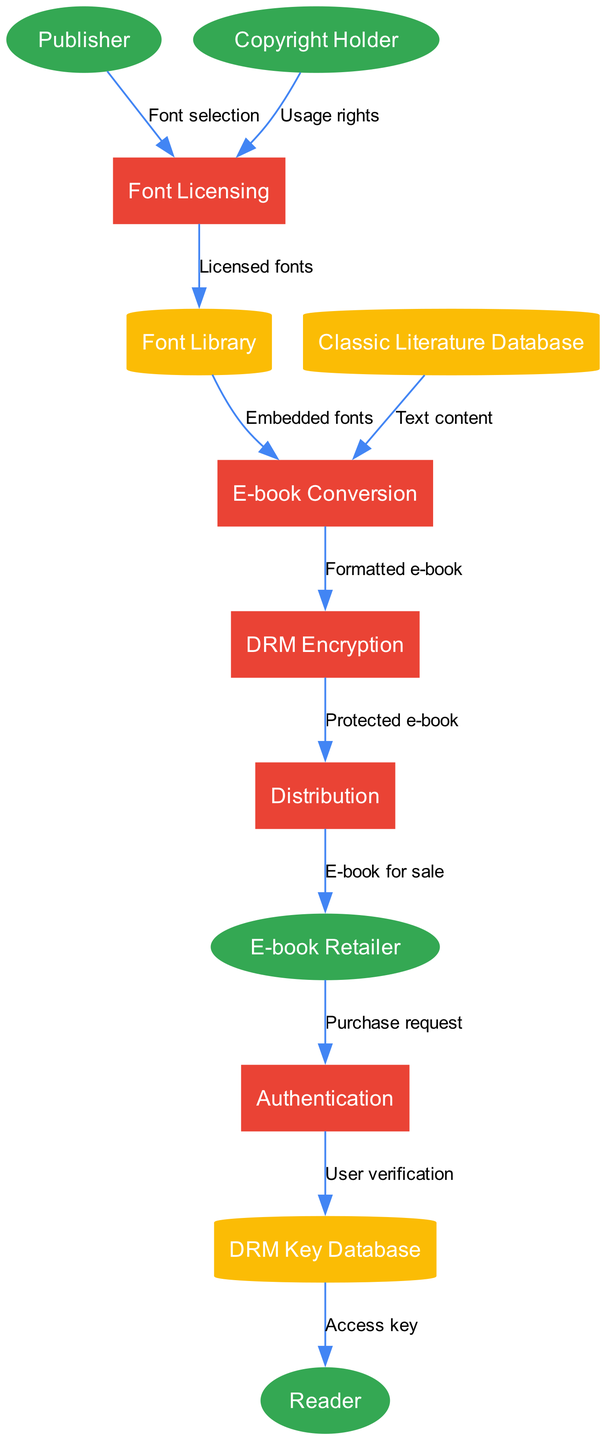What are the external entities in the diagram? The external entities listed in the diagram include Publisher, Copyright Holder, E-book Retailer, and Reader. Each entity represents a different stakeholder in the digital rights management process.
Answer: Publisher, Copyright Holder, E-book Retailer, Reader How many processes are there in the diagram? The diagram includes five processes: Font Licensing, E-book Conversion, DRM Encryption, Distribution, and Authentication. These processes represent the main activities in the digital rights management workflow.
Answer: Five What is the relationship between the Publisher and Font Licensing? The relationship is established by the data flow labeled "Font selection," indicating that the Publisher provides font selections to the Font Licensing process.
Answer: Font selection Which data store receives licensed fonts? The Font Library receives licensed fonts from the Font Licensing process. This indicates that approved fonts are stored in the Font Library for future use in the e-book conversion process.
Answer: Font Library How does a Reader obtain an access key? The Reader obtains an access key through a process flow that starts with the E-book Retailer sending a purchase request to the Authentication process, which then verifies the user against the DRM Key Database and provides the access key.
Answer: Access key What is the flow of the e-book after DRM Encryption? After the DRM Encryption process, the protected e-book is sent to the Distribution process, which handles the delivery of the e-book to the E-book Retailer for sale.
Answer: Protected e-book Which two data stores are directly involved in the E-book Conversion process? The two data stores involved are the Classic Literature Database, which provides text content, and the Font Library, which supplies embedded fonts needed for formatting the e-book.
Answer: Classic Literature Database, Font Library What is the last external entity that interacts with the process? The last external entity that interacts with the process is the Reader, who receives the access key after user verification from the Authentication process.
Answer: Reader 